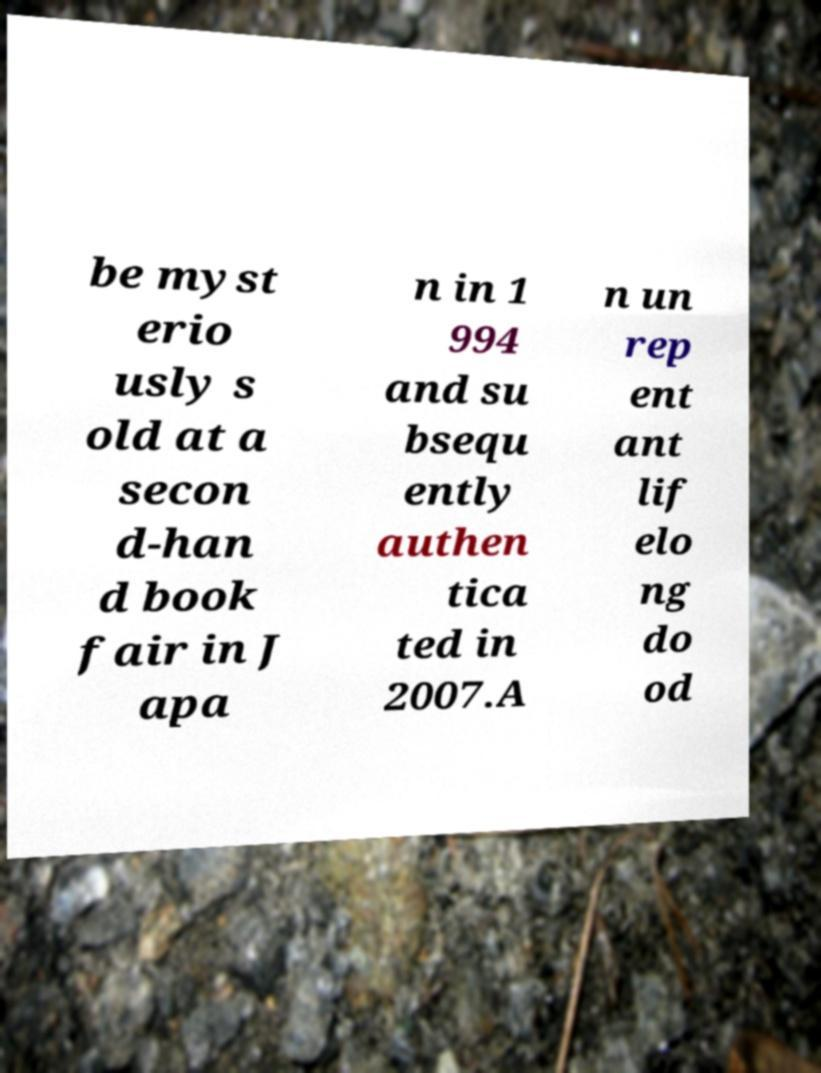For documentation purposes, I need the text within this image transcribed. Could you provide that? be myst erio usly s old at a secon d-han d book fair in J apa n in 1 994 and su bsequ ently authen tica ted in 2007.A n un rep ent ant lif elo ng do od 